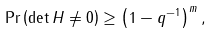Convert formula to latex. <formula><loc_0><loc_0><loc_500><loc_500>\Pr \left ( \det H \neq 0 \right ) \geq \left ( 1 - q ^ { - 1 } \right ) ^ { m } ,</formula> 